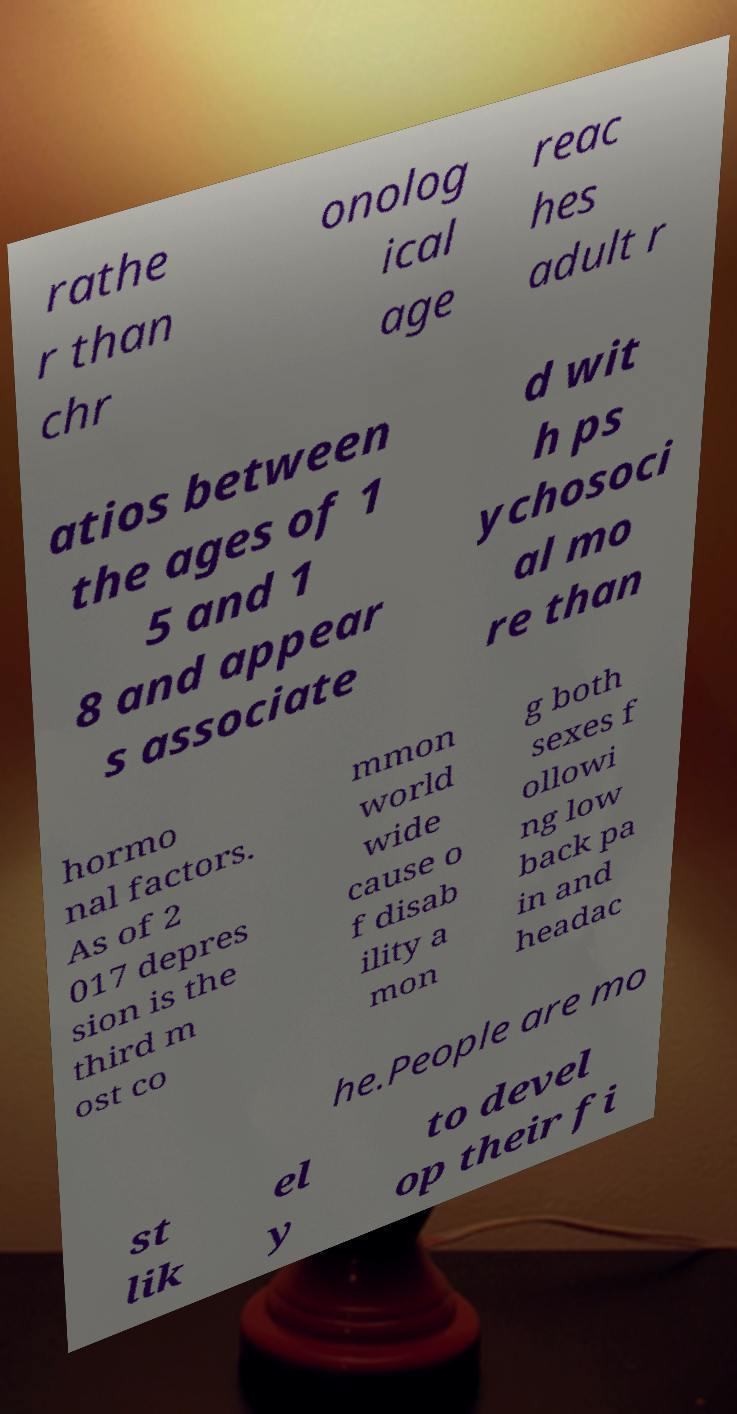Please read and relay the text visible in this image. What does it say? rathe r than chr onolog ical age reac hes adult r atios between the ages of 1 5 and 1 8 and appear s associate d wit h ps ychosoci al mo re than hormo nal factors. As of 2 017 depres sion is the third m ost co mmon world wide cause o f disab ility a mon g both sexes f ollowi ng low back pa in and headac he.People are mo st lik el y to devel op their fi 